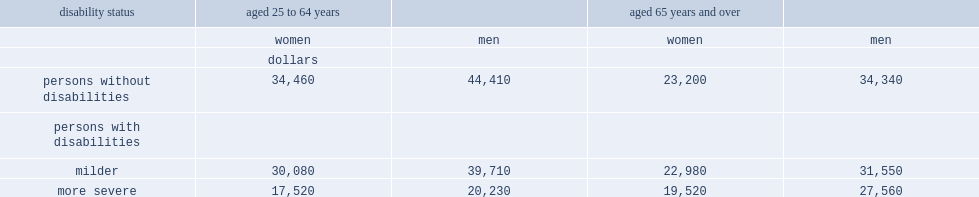What is the fraction of median income of working age women without disabilities and those with milder disabilities to that of their male counterparts? 0.775951 0.757492. Among those with more severe disabilities, what is the percent of women's income to men's. 0.866041. Among seniors aged 65 years and overs, what fraction of male's median income is equal to female's median income. 0.675597 0.728368 0.708273. Among those with more severe disabilities only,which age group had a high level of median income? aged 65 years and over or aged 25 to 64 years? Aged 65 years and over. 